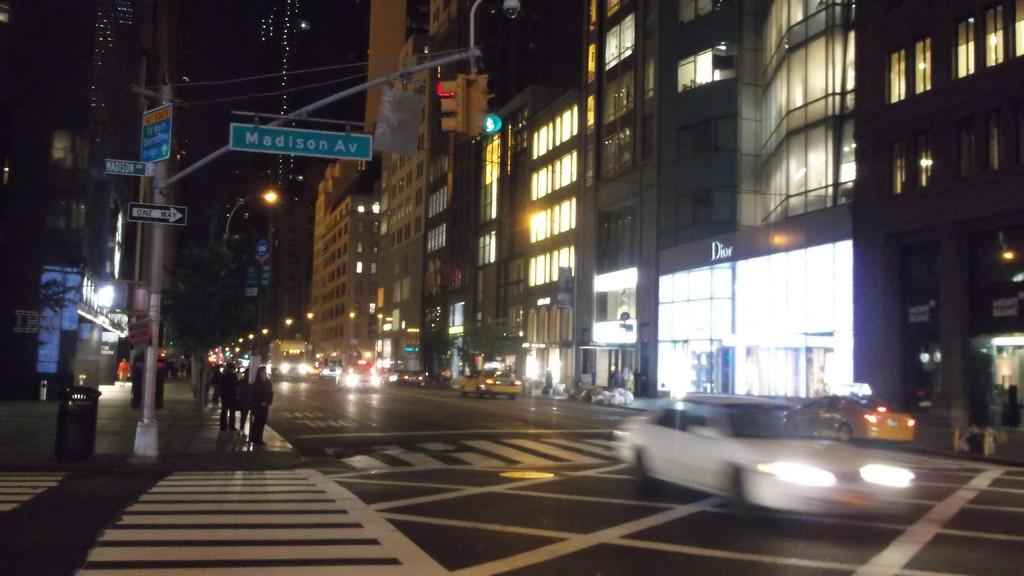Who or what can be seen in the image? There are people in the image. What objects are present in the image that provide information or directions? There are sign boards in the image. What structures can be seen in the image that support or hold up other objects? There are poles in the image. What type of transportation is visible on the road in the image? There are vehicles on the road in the image. What can be seen in the distance in the image? There are buildings and lights in the background of the image. What type of ice can be seen melting on the sign board in the image? There is no ice present in the image, let alone melting on the sign board. 